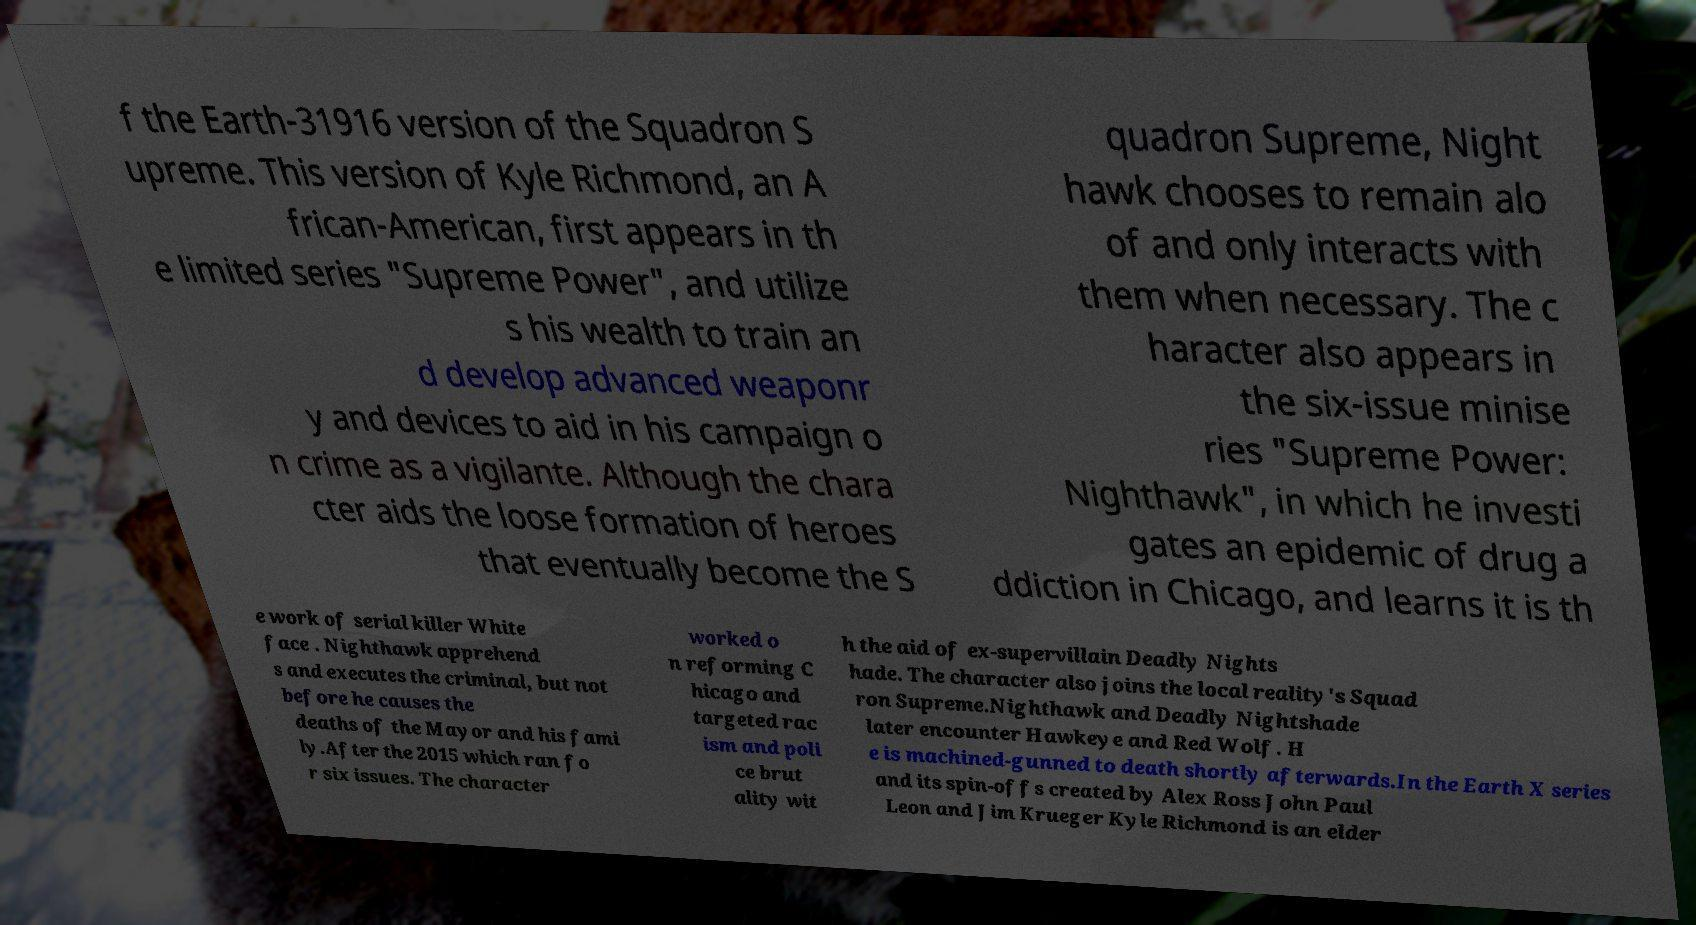Can you accurately transcribe the text from the provided image for me? f the Earth-31916 version of the Squadron S upreme. This version of Kyle Richmond, an A frican-American, first appears in th e limited series "Supreme Power", and utilize s his wealth to train an d develop advanced weaponr y and devices to aid in his campaign o n crime as a vigilante. Although the chara cter aids the loose formation of heroes that eventually become the S quadron Supreme, Night hawk chooses to remain alo of and only interacts with them when necessary. The c haracter also appears in the six-issue minise ries "Supreme Power: Nighthawk", in which he investi gates an epidemic of drug a ddiction in Chicago, and learns it is th e work of serial killer White face . Nighthawk apprehend s and executes the criminal, but not before he causes the deaths of the Mayor and his fami ly.After the 2015 which ran fo r six issues. The character worked o n reforming C hicago and targeted rac ism and poli ce brut ality wit h the aid of ex-supervillain Deadly Nights hade. The character also joins the local reality's Squad ron Supreme.Nighthawk and Deadly Nightshade later encounter Hawkeye and Red Wolf. H e is machined-gunned to death shortly afterwards.In the Earth X series and its spin-offs created by Alex Ross John Paul Leon and Jim Krueger Kyle Richmond is an elder 